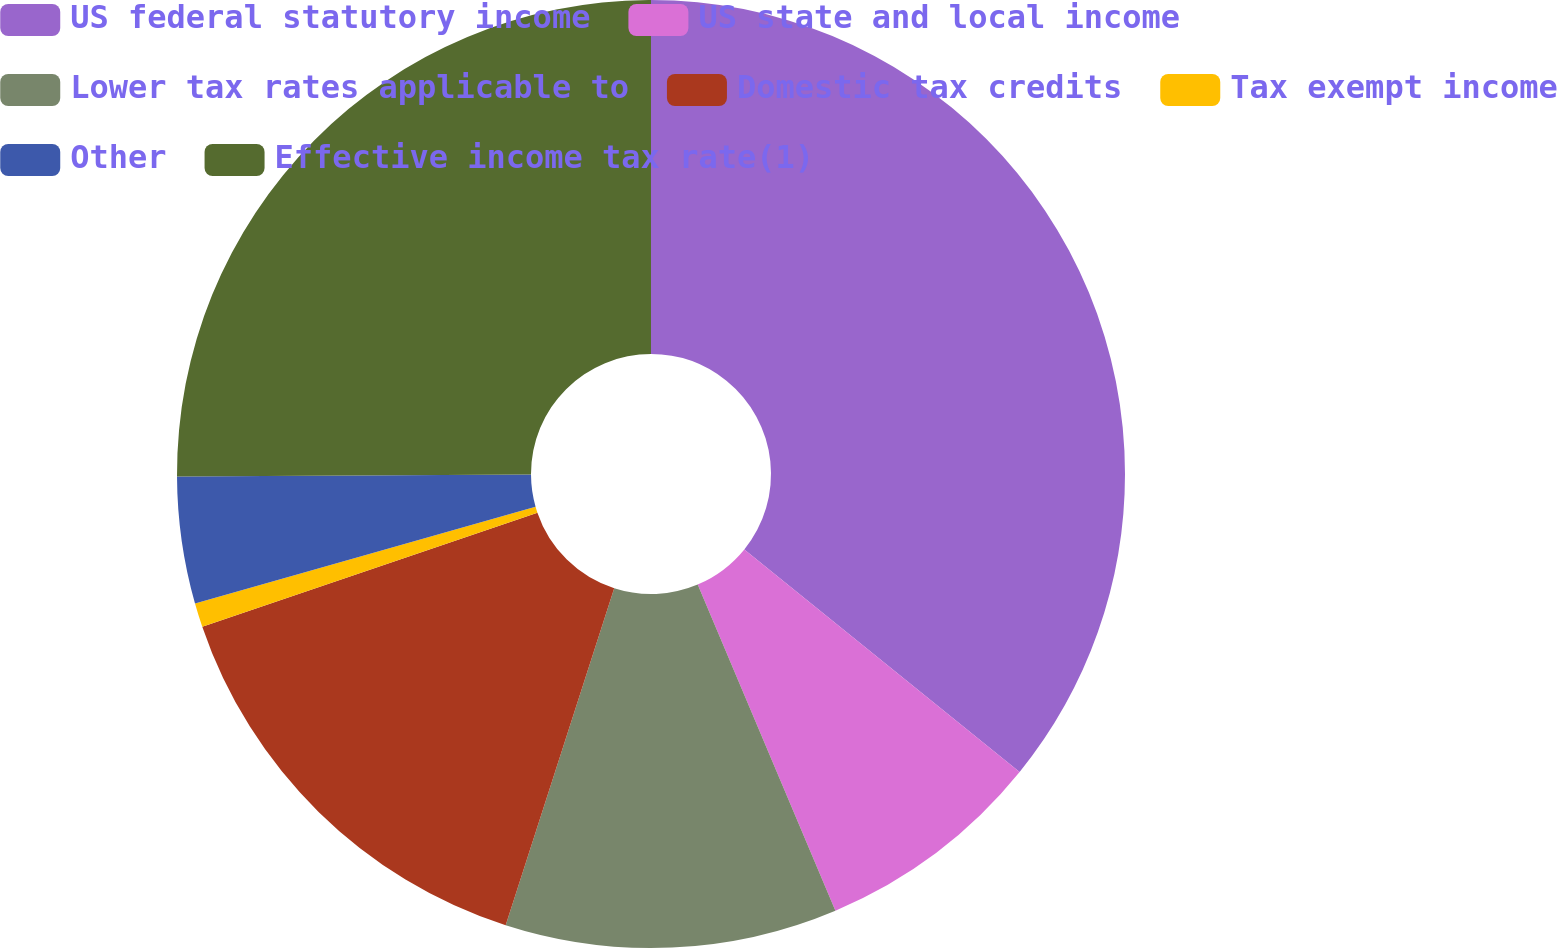Convert chart to OTSL. <chart><loc_0><loc_0><loc_500><loc_500><pie_chart><fcel>US federal statutory income<fcel>US state and local income<fcel>Lower tax rates applicable to<fcel>Domestic tax credits<fcel>Tax exempt income<fcel>Other<fcel>Effective income tax rate(1)<nl><fcel>35.82%<fcel>7.82%<fcel>11.32%<fcel>14.82%<fcel>0.82%<fcel>4.32%<fcel>25.08%<nl></chart> 